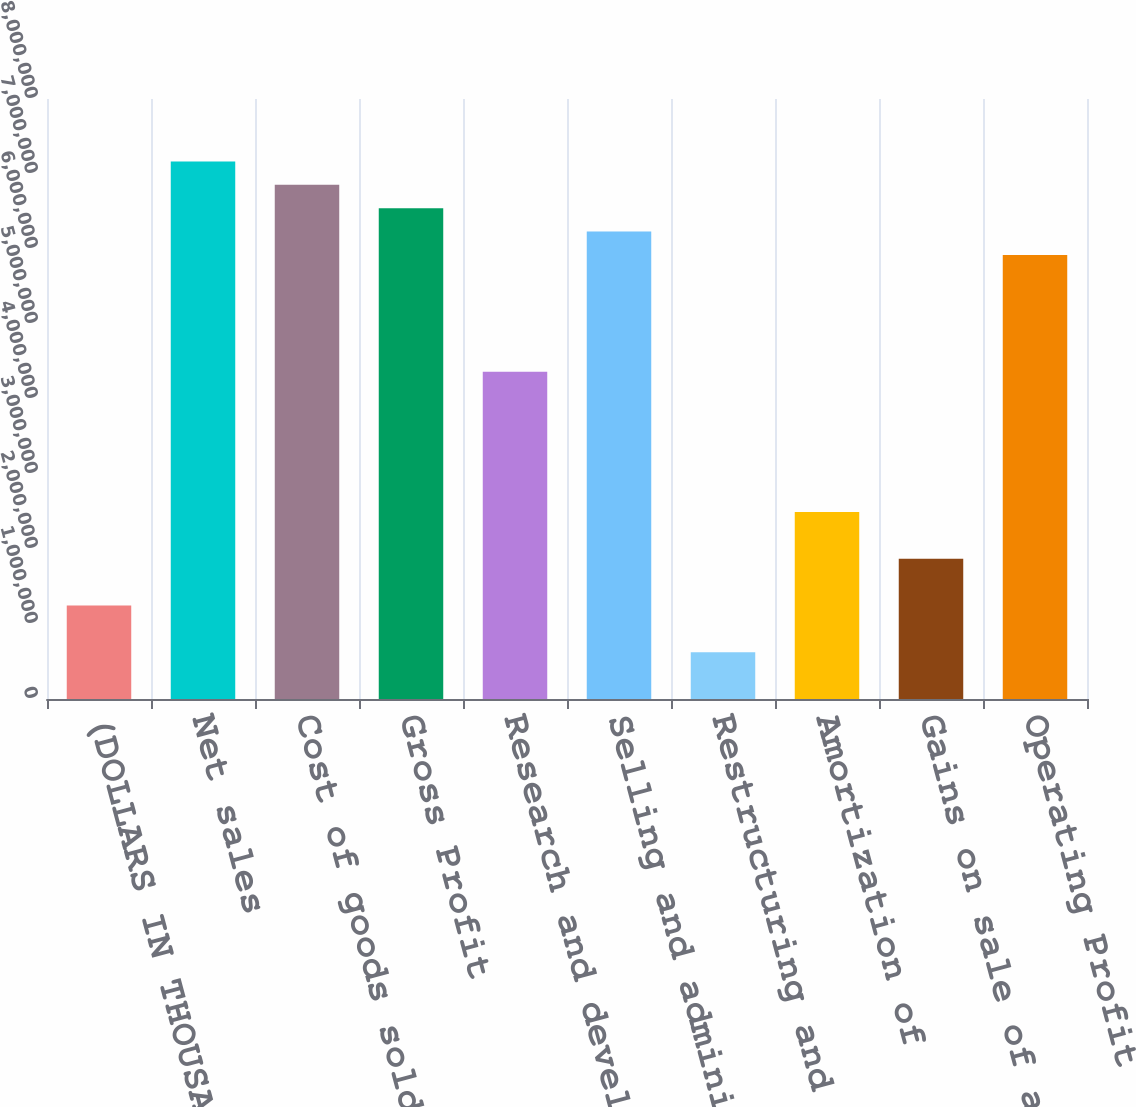Convert chart. <chart><loc_0><loc_0><loc_500><loc_500><bar_chart><fcel>(DOLLARS IN THOUSANDS EXCEPT<fcel>Net sales<fcel>Cost of goods sold<fcel>Gross Profit<fcel>Research and development<fcel>Selling and administrative<fcel>Restructuring and other<fcel>Amortization of<fcel>Gains on sale of assets<fcel>Operating Profit<nl><fcel>1.24654e+06<fcel>7.1676e+06<fcel>6.85596e+06<fcel>6.54433e+06<fcel>4.36289e+06<fcel>6.2327e+06<fcel>623274<fcel>2.49308e+06<fcel>1.86981e+06<fcel>5.92106e+06<nl></chart> 